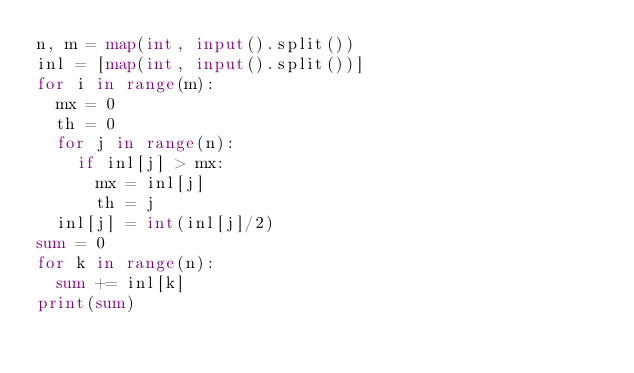Convert code to text. <code><loc_0><loc_0><loc_500><loc_500><_Python_>n, m = map(int, input().split())
inl = [map(int, input().split())]
for i in range(m):
  mx = 0
  th = 0
  for j in range(n):
    if inl[j] > mx:
      mx = inl[j]
      th = j
  inl[j] = int(inl[j]/2)
sum = 0
for k in range(n):
  sum += inl[k]
print(sum)
</code> 